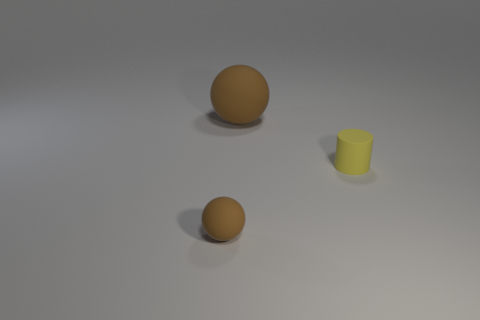Add 2 yellow cylinders. How many objects exist? 5 Subtract 1 cylinders. How many cylinders are left? 0 Subtract all balls. How many objects are left? 1 Subtract all blue cylinders. Subtract all green blocks. How many cylinders are left? 1 Subtract all gray balls. How many cyan cylinders are left? 0 Subtract all big red metal cylinders. Subtract all tiny brown rubber balls. How many objects are left? 2 Add 3 small objects. How many small objects are left? 5 Add 2 brown things. How many brown things exist? 4 Subtract 0 green cylinders. How many objects are left? 3 